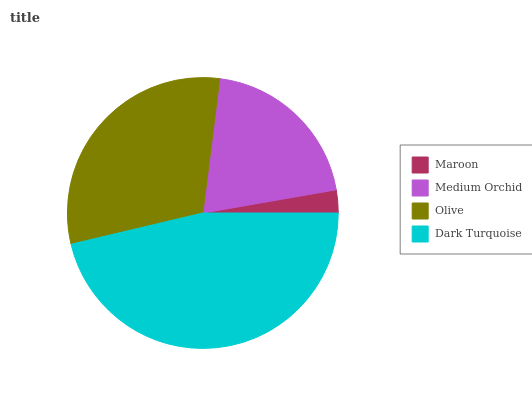Is Maroon the minimum?
Answer yes or no. Yes. Is Dark Turquoise the maximum?
Answer yes or no. Yes. Is Medium Orchid the minimum?
Answer yes or no. No. Is Medium Orchid the maximum?
Answer yes or no. No. Is Medium Orchid greater than Maroon?
Answer yes or no. Yes. Is Maroon less than Medium Orchid?
Answer yes or no. Yes. Is Maroon greater than Medium Orchid?
Answer yes or no. No. Is Medium Orchid less than Maroon?
Answer yes or no. No. Is Olive the high median?
Answer yes or no. Yes. Is Medium Orchid the low median?
Answer yes or no. Yes. Is Dark Turquoise the high median?
Answer yes or no. No. Is Olive the low median?
Answer yes or no. No. 